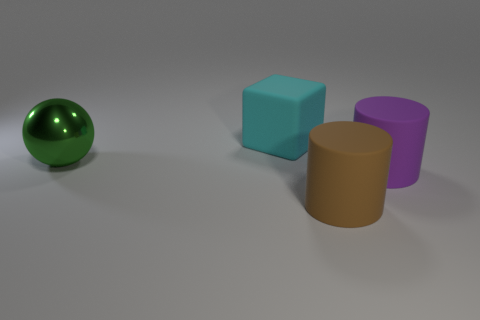Add 3 things. How many objects exist? 7 Subtract all spheres. How many objects are left? 3 Add 3 objects. How many objects are left? 7 Add 2 brown cylinders. How many brown cylinders exist? 3 Subtract 0 red balls. How many objects are left? 4 Subtract all large purple rubber cylinders. Subtract all large yellow metallic spheres. How many objects are left? 3 